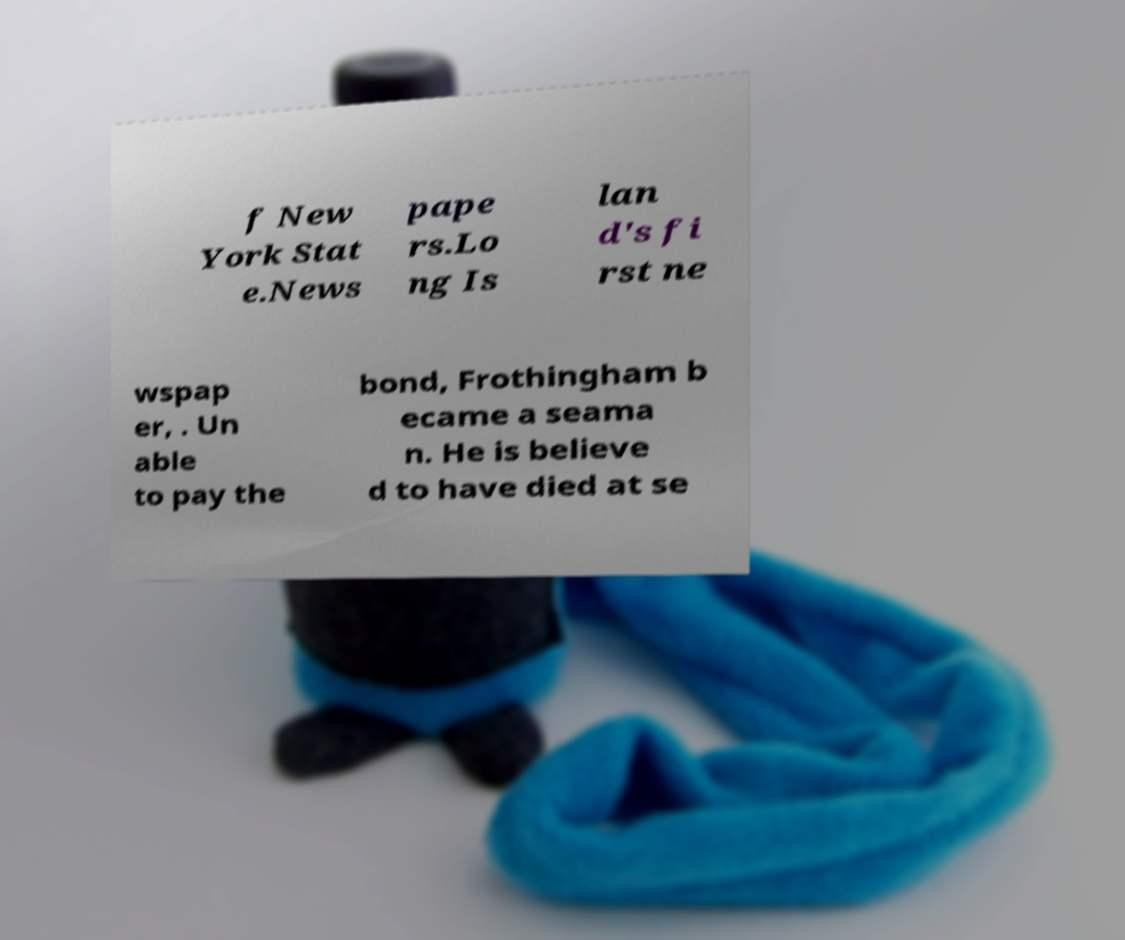Could you extract and type out the text from this image? f New York Stat e.News pape rs.Lo ng Is lan d's fi rst ne wspap er, . Un able to pay the bond, Frothingham b ecame a seama n. He is believe d to have died at se 